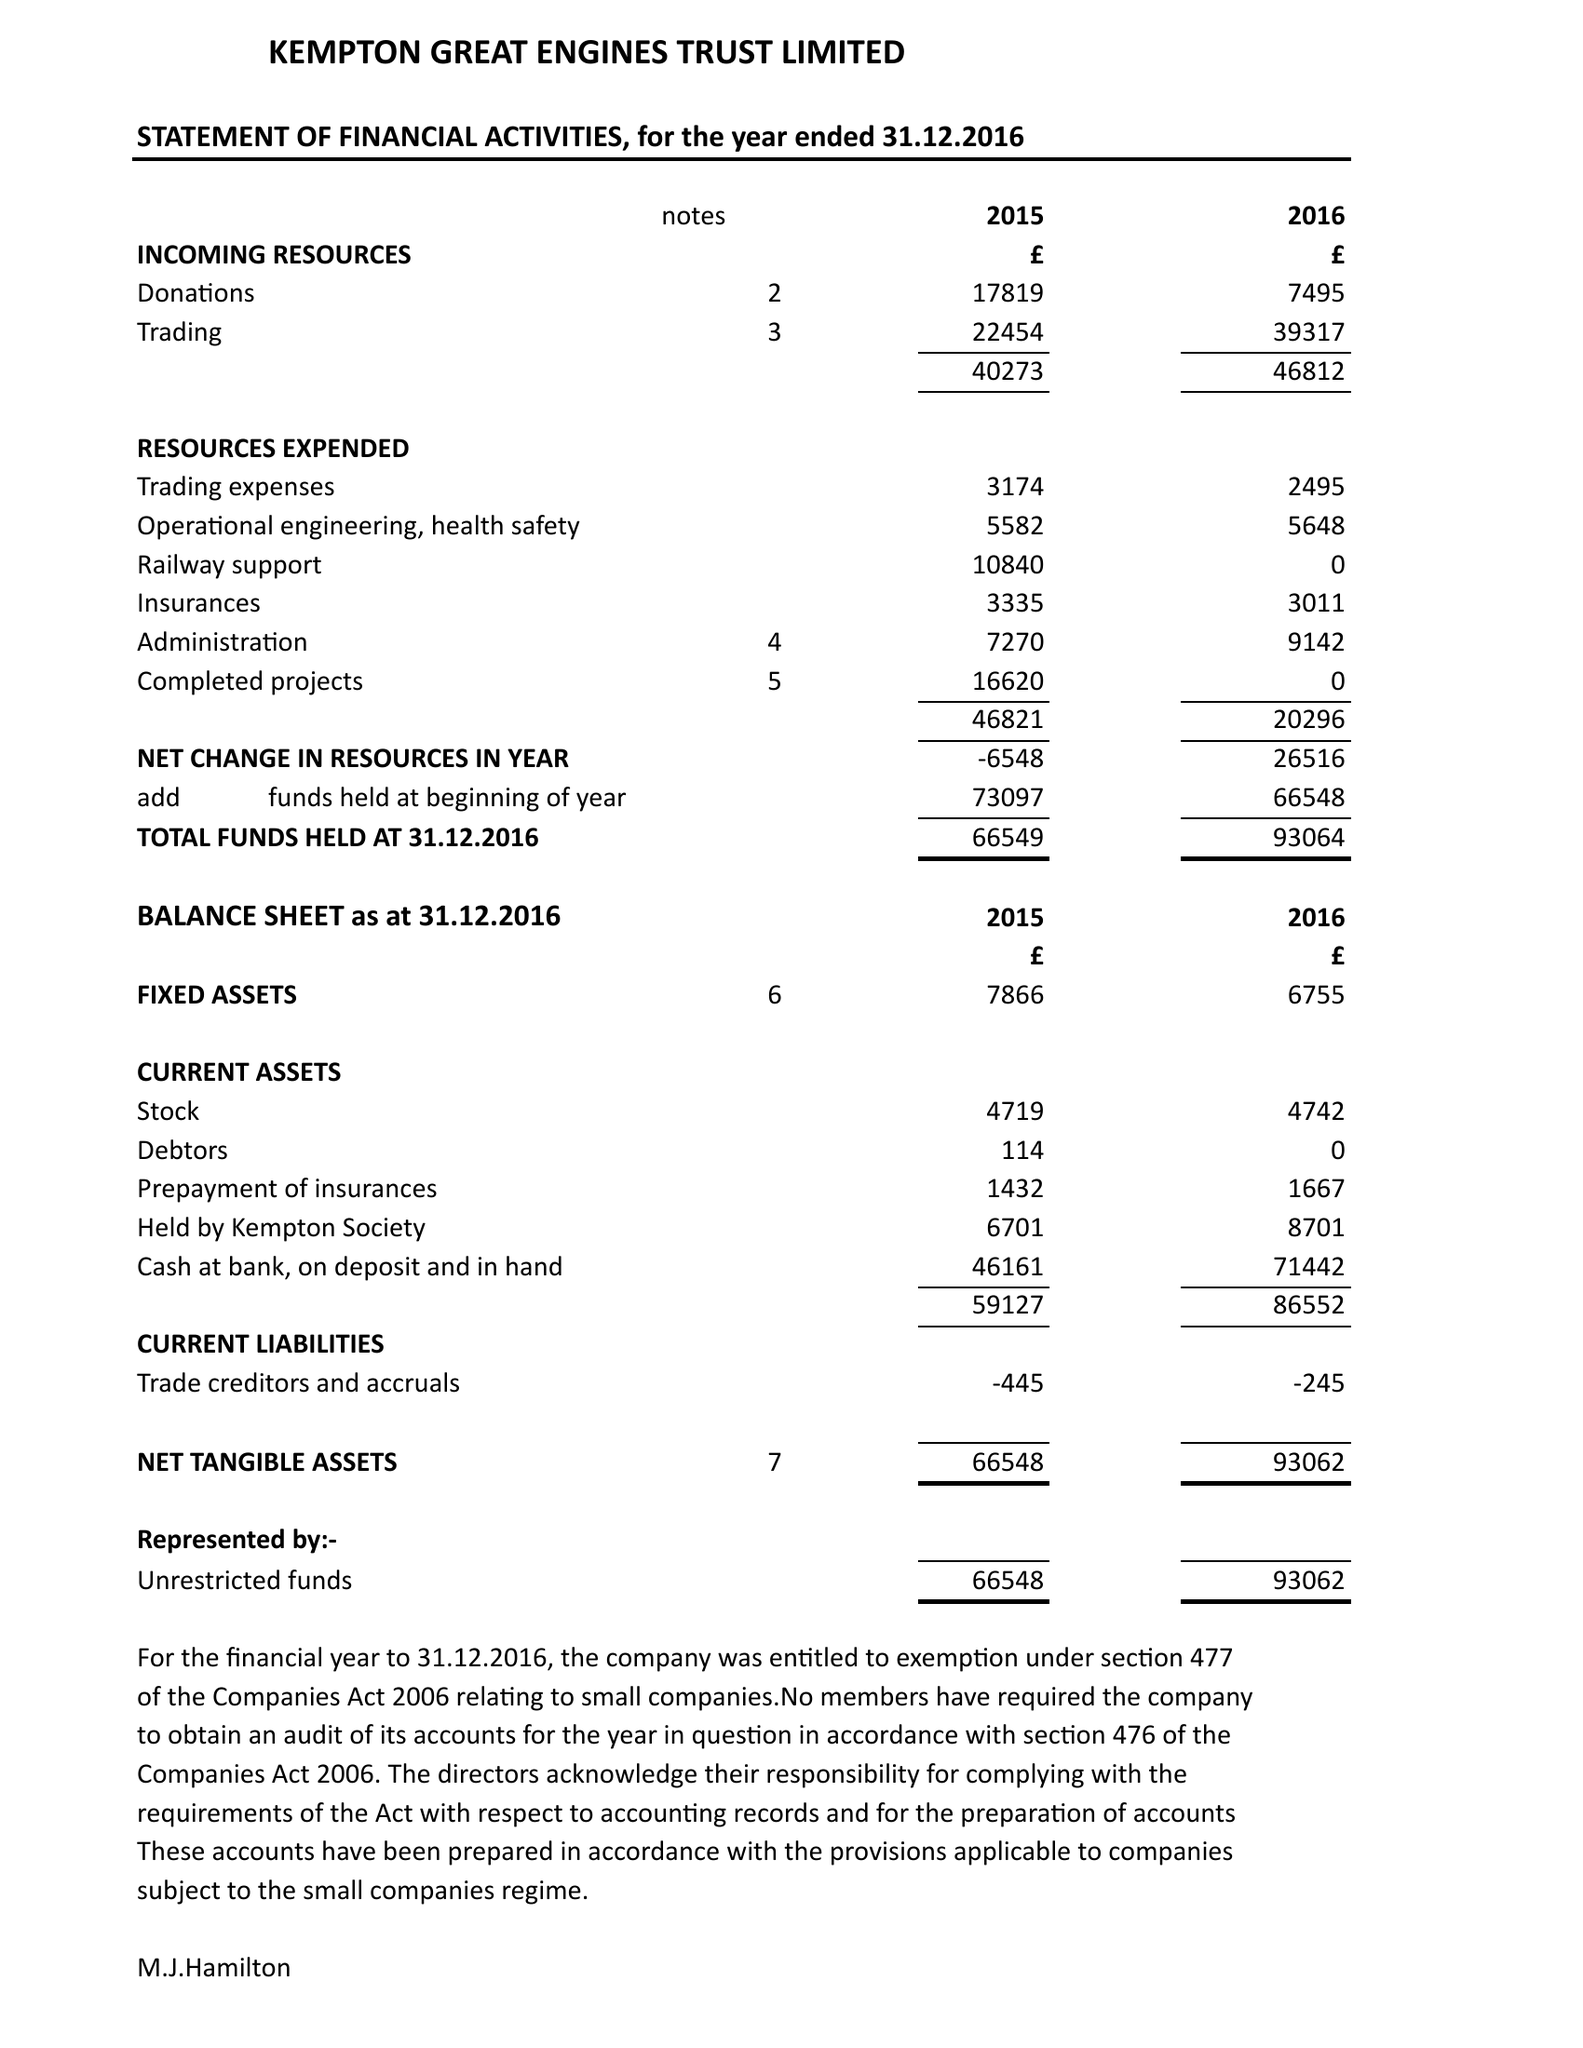What is the value for the address__post_town?
Answer the question using a single word or phrase. FELTHAM 